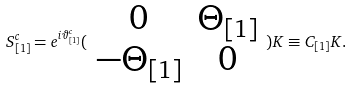Convert formula to latex. <formula><loc_0><loc_0><loc_500><loc_500>S _ { [ 1 ] } ^ { c } = e ^ { i \vartheta _ { [ 1 ] } ^ { c } } ( \begin{array} { c c } 0 & \Theta _ { [ 1 ] } \\ - \Theta _ { [ 1 ] } & 0 \end{array} ) K \equiv C _ { [ 1 ] } K .</formula> 